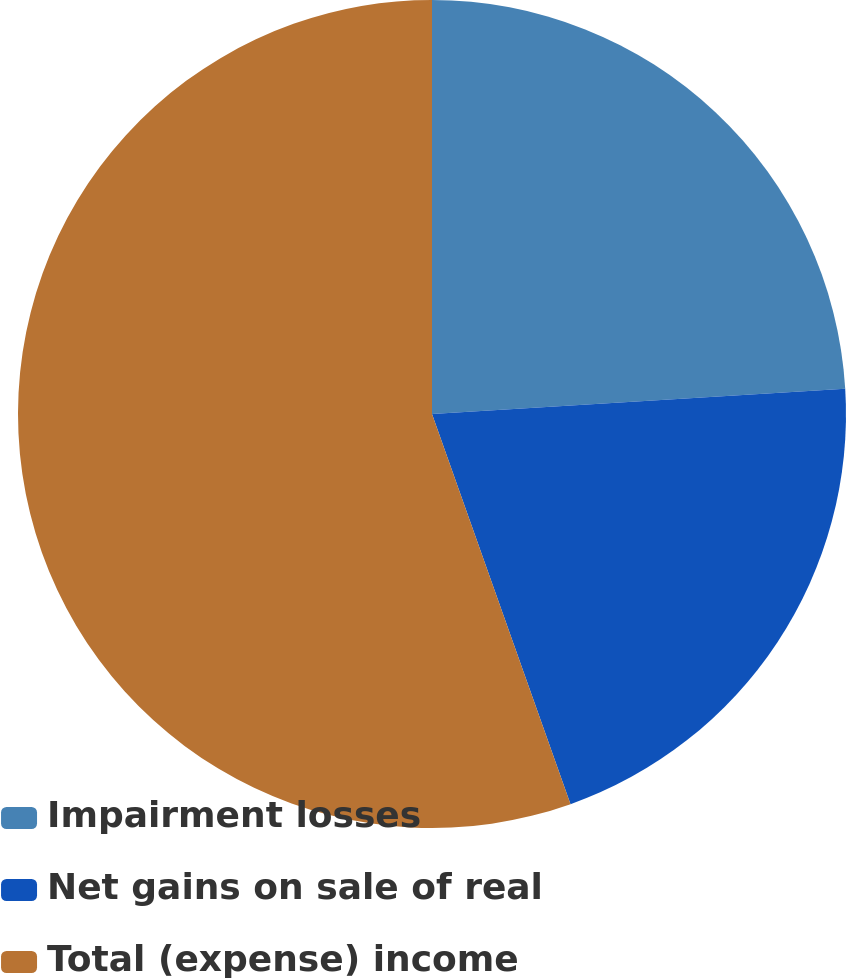Convert chart to OTSL. <chart><loc_0><loc_0><loc_500><loc_500><pie_chart><fcel>Impairment losses<fcel>Net gains on sale of real<fcel>Total (expense) income<nl><fcel>24.03%<fcel>20.54%<fcel>55.43%<nl></chart> 